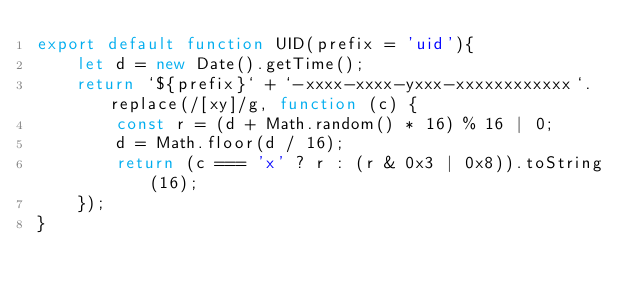<code> <loc_0><loc_0><loc_500><loc_500><_JavaScript_>export default function UID(prefix = 'uid'){
    let d = new Date().getTime();
    return `${prefix}` + `-xxxx-xxxx-yxxx-xxxxxxxxxxxx`.replace(/[xy]/g, function (c) {
        const r = (d + Math.random() * 16) % 16 | 0;
        d = Math.floor(d / 16);
        return (c === 'x' ? r : (r & 0x3 | 0x8)).toString(16);
    });
}</code> 